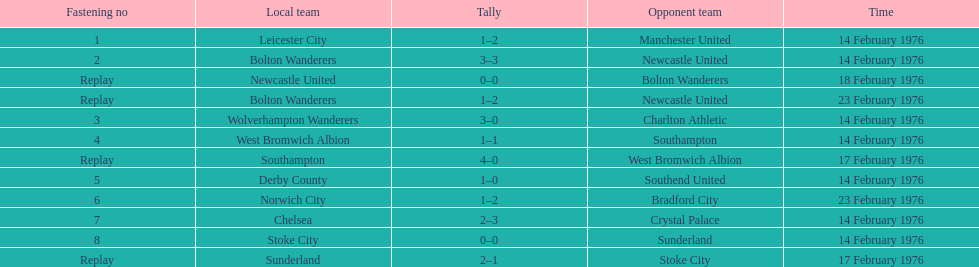How many games did the bolton wanderers and newcastle united play before there was a definitive winner in the fifth round proper? 3. Write the full table. {'header': ['Fastening no', 'Local team', 'Tally', 'Opponent team', 'Time'], 'rows': [['1', 'Leicester City', '1–2', 'Manchester United', '14 February 1976'], ['2', 'Bolton Wanderers', '3–3', 'Newcastle United', '14 February 1976'], ['Replay', 'Newcastle United', '0–0', 'Bolton Wanderers', '18 February 1976'], ['Replay', 'Bolton Wanderers', '1–2', 'Newcastle United', '23 February 1976'], ['3', 'Wolverhampton Wanderers', '3–0', 'Charlton Athletic', '14 February 1976'], ['4', 'West Bromwich Albion', '1–1', 'Southampton', '14 February 1976'], ['Replay', 'Southampton', '4–0', 'West Bromwich Albion', '17 February 1976'], ['5', 'Derby County', '1–0', 'Southend United', '14 February 1976'], ['6', 'Norwich City', '1–2', 'Bradford City', '23 February 1976'], ['7', 'Chelsea', '2–3', 'Crystal Palace', '14 February 1976'], ['8', 'Stoke City', '0–0', 'Sunderland', '14 February 1976'], ['Replay', 'Sunderland', '2–1', 'Stoke City', '17 February 1976']]} 